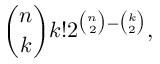Convert formula to latex. <formula><loc_0><loc_0><loc_500><loc_500>{ \binom { n } { k } } k ! 2 ^ { { \binom { n } { 2 } } - { \binom { k } { 2 } } } ,</formula> 